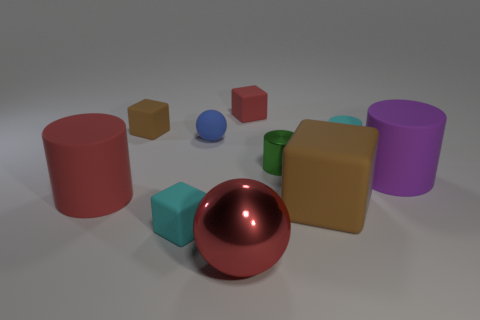There is a big block; is its color the same as the tiny matte object that is on the left side of the tiny cyan block?
Offer a very short reply. Yes. Does the green cylinder have the same material as the tiny cyan cube that is in front of the red rubber cylinder?
Make the answer very short. No. There is a green thing that is the same shape as the purple object; what material is it?
Provide a succinct answer. Metal. There is a red object that is to the right of the blue rubber sphere and in front of the small cyan rubber cylinder; what is its material?
Provide a succinct answer. Metal. There is a purple matte object; is it the same size as the brown matte block that is left of the red rubber cube?
Provide a short and direct response. No. Are there an equal number of tiny matte cubes that are to the left of the small metallic cylinder and large purple matte things on the right side of the tiny red cube?
Ensure brevity in your answer.  No. There is a big matte object that is the same color as the large metal sphere; what shape is it?
Your response must be concise. Cylinder. What is the material of the red thing in front of the cyan cube?
Provide a succinct answer. Metal. Do the cyan block and the purple object have the same size?
Offer a terse response. No. Are there more cyan objects that are right of the small shiny cylinder than gray matte spheres?
Keep it short and to the point. Yes. 